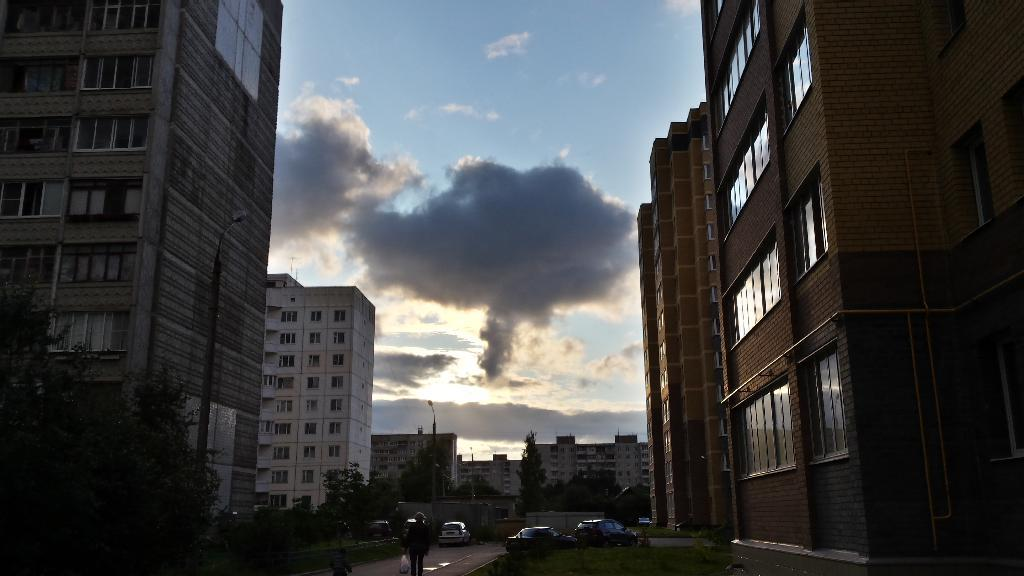What type of structures can be seen in the image? There are buildings in the image. What natural elements are present in the image? There are trees and grass in the image. What man-made objects can be seen in the image? There are vehicles in the image. Are there any living beings in the image? Yes, there are persons in the image. What is visible in the background of the image? The sky is visible in the background of the image, and clouds are present in the sky. What type of toys can be seen in the image? There are no toys present in the image. Is there any magic happening in the image? There is no indication of magic in the image. 